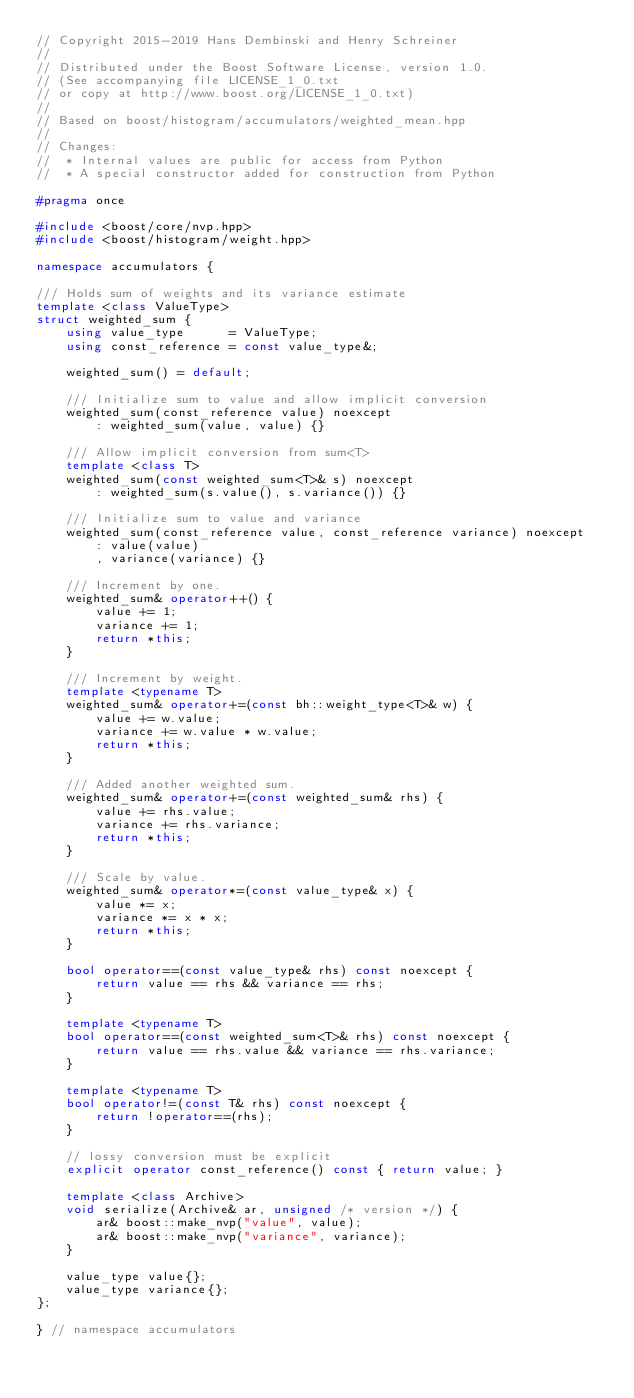<code> <loc_0><loc_0><loc_500><loc_500><_C++_>// Copyright 2015-2019 Hans Dembinski and Henry Schreiner
//
// Distributed under the Boost Software License, version 1.0.
// (See accompanying file LICENSE_1_0.txt
// or copy at http://www.boost.org/LICENSE_1_0.txt)
//
// Based on boost/histogram/accumulators/weighted_mean.hpp
//
// Changes:
//  * Internal values are public for access from Python
//  * A special constructor added for construction from Python

#pragma once

#include <boost/core/nvp.hpp>
#include <boost/histogram/weight.hpp>

namespace accumulators {

/// Holds sum of weights and its variance estimate
template <class ValueType>
struct weighted_sum {
    using value_type      = ValueType;
    using const_reference = const value_type&;

    weighted_sum() = default;

    /// Initialize sum to value and allow implicit conversion
    weighted_sum(const_reference value) noexcept
        : weighted_sum(value, value) {}

    /// Allow implicit conversion from sum<T>
    template <class T>
    weighted_sum(const weighted_sum<T>& s) noexcept
        : weighted_sum(s.value(), s.variance()) {}

    /// Initialize sum to value and variance
    weighted_sum(const_reference value, const_reference variance) noexcept
        : value(value)
        , variance(variance) {}

    /// Increment by one.
    weighted_sum& operator++() {
        value += 1;
        variance += 1;
        return *this;
    }

    /// Increment by weight.
    template <typename T>
    weighted_sum& operator+=(const bh::weight_type<T>& w) {
        value += w.value;
        variance += w.value * w.value;
        return *this;
    }

    /// Added another weighted sum.
    weighted_sum& operator+=(const weighted_sum& rhs) {
        value += rhs.value;
        variance += rhs.variance;
        return *this;
    }

    /// Scale by value.
    weighted_sum& operator*=(const value_type& x) {
        value *= x;
        variance *= x * x;
        return *this;
    }

    bool operator==(const value_type& rhs) const noexcept {
        return value == rhs && variance == rhs;
    }

    template <typename T>
    bool operator==(const weighted_sum<T>& rhs) const noexcept {
        return value == rhs.value && variance == rhs.variance;
    }

    template <typename T>
    bool operator!=(const T& rhs) const noexcept {
        return !operator==(rhs);
    }

    // lossy conversion must be explicit
    explicit operator const_reference() const { return value; }

    template <class Archive>
    void serialize(Archive& ar, unsigned /* version */) {
        ar& boost::make_nvp("value", value);
        ar& boost::make_nvp("variance", variance);
    }

    value_type value{};
    value_type variance{};
};

} // namespace accumulators
</code> 